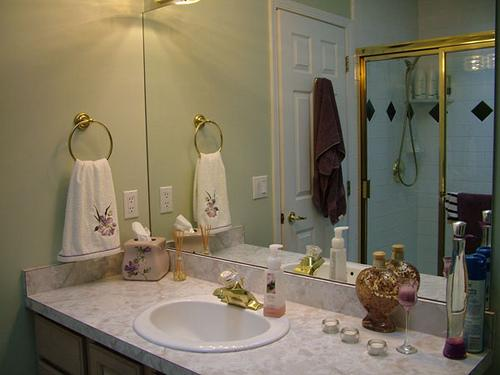What color is the faucet above of the sink?

Choices:
A) blue
B) black
C) silver
D) yellow yellow 